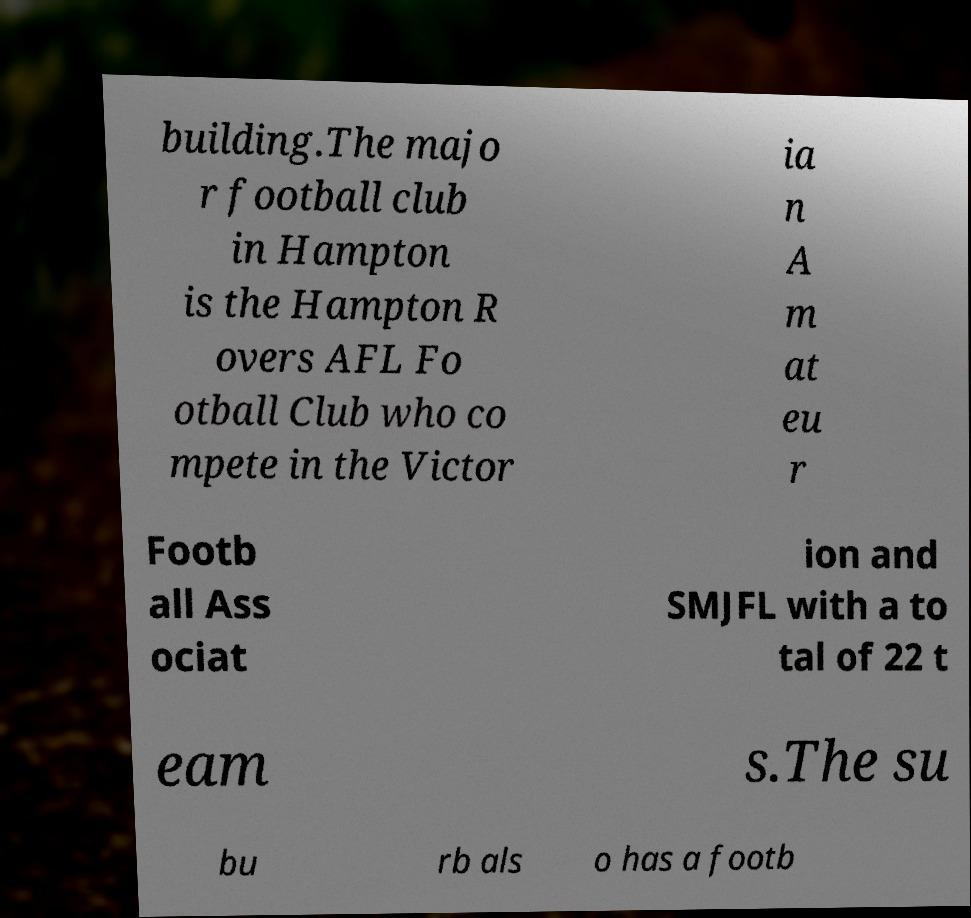Can you read and provide the text displayed in the image?This photo seems to have some interesting text. Can you extract and type it out for me? building.The majo r football club in Hampton is the Hampton R overs AFL Fo otball Club who co mpete in the Victor ia n A m at eu r Footb all Ass ociat ion and SMJFL with a to tal of 22 t eam s.The su bu rb als o has a footb 